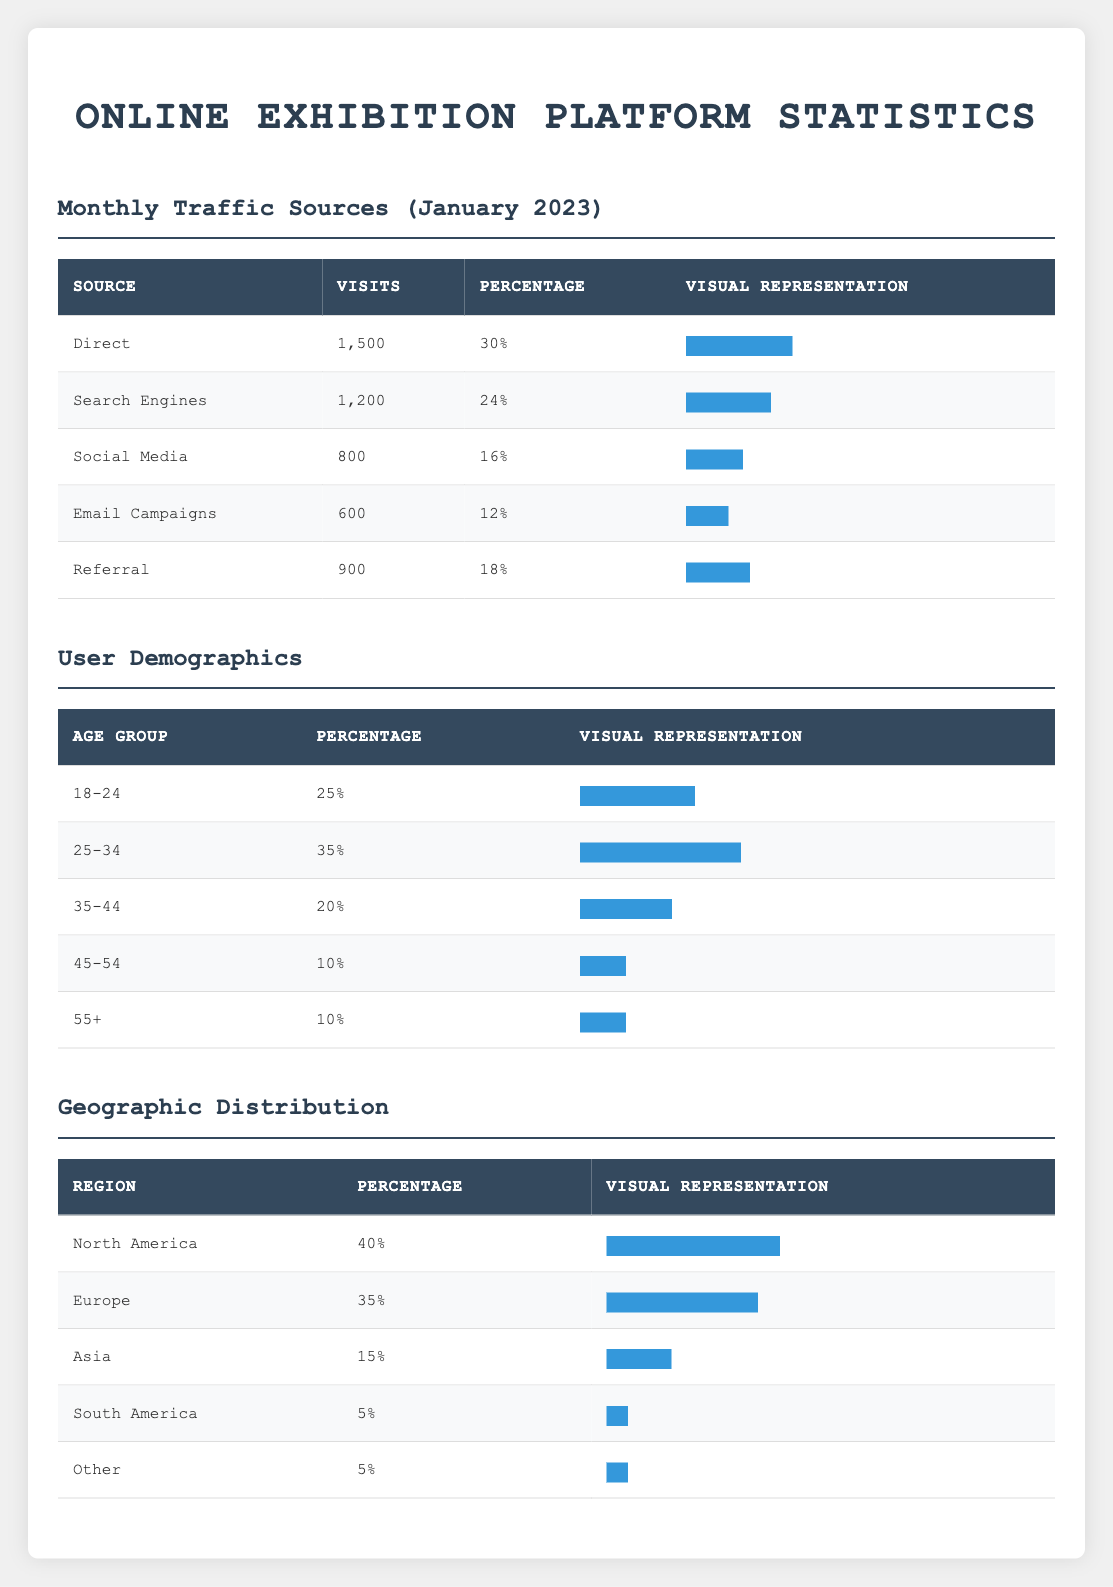What was the total number of visits from Email Campaigns in January 2023? The table shows that Email Campaigns had 600 visits in January 2023. Therefore, the total number of visits from this source is directly mentioned in the table.
Answer: 600 Which traffic source has the highest percentage of visits in January 2023? The table lists the percentage of visits for each source in January 2023. Scanning through the table, 'Direct' has the highest percentage of 30%.
Answer: Direct What is the percentage of users aged 35-44? Looking at the user demographics table, the percentage for the age group 35-44 is explicitly stated as 20%.
Answer: 20% What are the total percentage values for the age demographic groups combined? The total percentage values for the age groups are found by adding them together: 25 + 35 + 20 + 10 + 10 = 110%. Therefore, the total percentage across all demographics exceeds 100%.
Answer: 110% Is there a higher percentage of users from Europe or Asia? According to the geographic distribution table, Europe has a percentage of 35% while Asia has only 15%. Thus, Europe has a higher percentage of users.
Answer: Yes What percentage of traffic in January 2023 came from Search Engines and Social Media combined? To find the combined percentage from both sources, look at their individual percentages: Search Engines is 24% and Social Media is 16%. Adding these gives 24 + 16 = 40%.
Answer: 40% Which demographic has the lowest percentage in the age distribution? Reviewing the age demographics in the table, both the 45-54 and 55+ groups each have a percentage of 10%, which is the lowest compared to the others.
Answer: 45-54 and 55+ Is the user demographic from North America greater than that from Europe? The table states that North America comprises 40% of users while Europe accounts for 35%. Hence, North America represents a greater percentage of users.
Answer: Yes What percentage of the total visits in January 2023 were made from Referral sources? The table shows that Referral sources contributed 900 visits. The total visits from all sources are 1500 + 1200 + 800 + 600 + 900 = 4200. To find the percentage from Referrals, calculate (900/4200) * 100, which equals approximately 21.43%.
Answer: 21.43% 